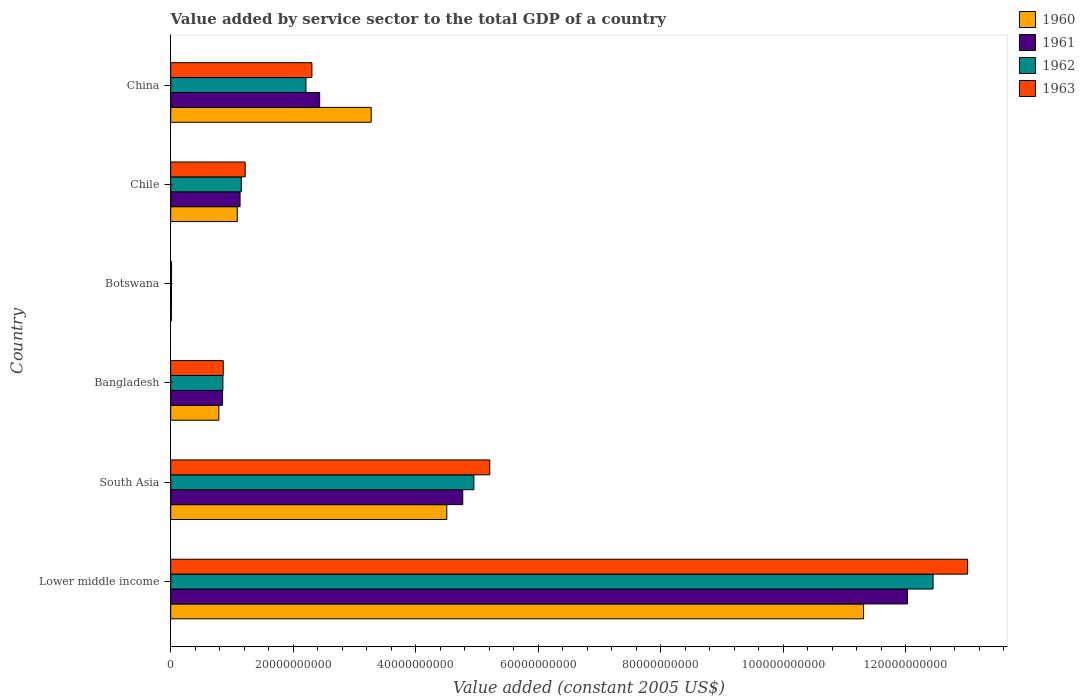How many different coloured bars are there?
Your answer should be very brief. 4. What is the label of the 1st group of bars from the top?
Provide a succinct answer. China. What is the value added by service sector in 1960 in South Asia?
Your response must be concise. 4.51e+1. Across all countries, what is the maximum value added by service sector in 1962?
Offer a very short reply. 1.24e+11. Across all countries, what is the minimum value added by service sector in 1963?
Provide a succinct answer. 1.45e+08. In which country was the value added by service sector in 1962 maximum?
Provide a succinct answer. Lower middle income. In which country was the value added by service sector in 1960 minimum?
Your answer should be very brief. Botswana. What is the total value added by service sector in 1962 in the graph?
Your answer should be very brief. 2.16e+11. What is the difference between the value added by service sector in 1960 in Bangladesh and that in Botswana?
Keep it short and to the point. 7.75e+09. What is the difference between the value added by service sector in 1962 in Chile and the value added by service sector in 1963 in China?
Your response must be concise. -1.15e+1. What is the average value added by service sector in 1962 per country?
Make the answer very short. 3.60e+1. What is the difference between the value added by service sector in 1963 and value added by service sector in 1961 in South Asia?
Make the answer very short. 4.41e+09. What is the ratio of the value added by service sector in 1961 in Lower middle income to that in South Asia?
Ensure brevity in your answer.  2.52. Is the value added by service sector in 1961 in Bangladesh less than that in South Asia?
Offer a terse response. Yes. What is the difference between the highest and the second highest value added by service sector in 1962?
Offer a very short reply. 7.50e+1. What is the difference between the highest and the lowest value added by service sector in 1962?
Offer a very short reply. 1.24e+11. Is the sum of the value added by service sector in 1961 in Botswana and South Asia greater than the maximum value added by service sector in 1962 across all countries?
Keep it short and to the point. No. Is it the case that in every country, the sum of the value added by service sector in 1961 and value added by service sector in 1962 is greater than the sum of value added by service sector in 1960 and value added by service sector in 1963?
Make the answer very short. No. What does the 1st bar from the top in South Asia represents?
Your response must be concise. 1963. Is it the case that in every country, the sum of the value added by service sector in 1962 and value added by service sector in 1963 is greater than the value added by service sector in 1961?
Provide a short and direct response. Yes. Are all the bars in the graph horizontal?
Your response must be concise. Yes. Does the graph contain any zero values?
Offer a very short reply. No. Does the graph contain grids?
Keep it short and to the point. No. How are the legend labels stacked?
Your answer should be very brief. Vertical. What is the title of the graph?
Keep it short and to the point. Value added by service sector to the total GDP of a country. Does "1986" appear as one of the legend labels in the graph?
Ensure brevity in your answer.  No. What is the label or title of the X-axis?
Your answer should be very brief. Value added (constant 2005 US$). What is the Value added (constant 2005 US$) of 1960 in Lower middle income?
Give a very brief answer. 1.13e+11. What is the Value added (constant 2005 US$) of 1961 in Lower middle income?
Offer a very short reply. 1.20e+11. What is the Value added (constant 2005 US$) of 1962 in Lower middle income?
Provide a succinct answer. 1.24e+11. What is the Value added (constant 2005 US$) of 1963 in Lower middle income?
Your answer should be very brief. 1.30e+11. What is the Value added (constant 2005 US$) in 1960 in South Asia?
Ensure brevity in your answer.  4.51e+1. What is the Value added (constant 2005 US$) in 1961 in South Asia?
Your answer should be compact. 4.77e+1. What is the Value added (constant 2005 US$) of 1962 in South Asia?
Your response must be concise. 4.95e+1. What is the Value added (constant 2005 US$) in 1963 in South Asia?
Offer a very short reply. 5.21e+1. What is the Value added (constant 2005 US$) of 1960 in Bangladesh?
Provide a succinct answer. 7.86e+09. What is the Value added (constant 2005 US$) in 1961 in Bangladesh?
Offer a terse response. 8.47e+09. What is the Value added (constant 2005 US$) in 1962 in Bangladesh?
Your response must be concise. 8.52e+09. What is the Value added (constant 2005 US$) of 1963 in Bangladesh?
Give a very brief answer. 8.58e+09. What is the Value added (constant 2005 US$) in 1960 in Botswana?
Your answer should be compact. 1.11e+08. What is the Value added (constant 2005 US$) in 1961 in Botswana?
Ensure brevity in your answer.  1.22e+08. What is the Value added (constant 2005 US$) in 1962 in Botswana?
Provide a succinct answer. 1.32e+08. What is the Value added (constant 2005 US$) in 1963 in Botswana?
Offer a very short reply. 1.45e+08. What is the Value added (constant 2005 US$) in 1960 in Chile?
Make the answer very short. 1.09e+1. What is the Value added (constant 2005 US$) of 1961 in Chile?
Offer a very short reply. 1.13e+1. What is the Value added (constant 2005 US$) of 1962 in Chile?
Give a very brief answer. 1.15e+1. What is the Value added (constant 2005 US$) in 1963 in Chile?
Give a very brief answer. 1.22e+1. What is the Value added (constant 2005 US$) of 1960 in China?
Your response must be concise. 3.27e+1. What is the Value added (constant 2005 US$) in 1961 in China?
Offer a terse response. 2.43e+1. What is the Value added (constant 2005 US$) in 1962 in China?
Offer a terse response. 2.21e+1. What is the Value added (constant 2005 US$) of 1963 in China?
Provide a short and direct response. 2.30e+1. Across all countries, what is the maximum Value added (constant 2005 US$) in 1960?
Ensure brevity in your answer.  1.13e+11. Across all countries, what is the maximum Value added (constant 2005 US$) of 1961?
Ensure brevity in your answer.  1.20e+11. Across all countries, what is the maximum Value added (constant 2005 US$) in 1962?
Offer a very short reply. 1.24e+11. Across all countries, what is the maximum Value added (constant 2005 US$) in 1963?
Provide a succinct answer. 1.30e+11. Across all countries, what is the minimum Value added (constant 2005 US$) in 1960?
Offer a very short reply. 1.11e+08. Across all countries, what is the minimum Value added (constant 2005 US$) of 1961?
Keep it short and to the point. 1.22e+08. Across all countries, what is the minimum Value added (constant 2005 US$) in 1962?
Provide a short and direct response. 1.32e+08. Across all countries, what is the minimum Value added (constant 2005 US$) in 1963?
Offer a terse response. 1.45e+08. What is the total Value added (constant 2005 US$) in 1960 in the graph?
Offer a terse response. 2.10e+11. What is the total Value added (constant 2005 US$) of 1961 in the graph?
Provide a succinct answer. 2.12e+11. What is the total Value added (constant 2005 US$) of 1962 in the graph?
Ensure brevity in your answer.  2.16e+11. What is the total Value added (constant 2005 US$) in 1963 in the graph?
Give a very brief answer. 2.26e+11. What is the difference between the Value added (constant 2005 US$) in 1960 in Lower middle income and that in South Asia?
Keep it short and to the point. 6.80e+1. What is the difference between the Value added (constant 2005 US$) of 1961 in Lower middle income and that in South Asia?
Your answer should be very brief. 7.26e+1. What is the difference between the Value added (constant 2005 US$) of 1962 in Lower middle income and that in South Asia?
Ensure brevity in your answer.  7.50e+1. What is the difference between the Value added (constant 2005 US$) of 1963 in Lower middle income and that in South Asia?
Provide a succinct answer. 7.80e+1. What is the difference between the Value added (constant 2005 US$) of 1960 in Lower middle income and that in Bangladesh?
Offer a terse response. 1.05e+11. What is the difference between the Value added (constant 2005 US$) in 1961 in Lower middle income and that in Bangladesh?
Your answer should be compact. 1.12e+11. What is the difference between the Value added (constant 2005 US$) in 1962 in Lower middle income and that in Bangladesh?
Give a very brief answer. 1.16e+11. What is the difference between the Value added (constant 2005 US$) of 1963 in Lower middle income and that in Bangladesh?
Offer a very short reply. 1.21e+11. What is the difference between the Value added (constant 2005 US$) of 1960 in Lower middle income and that in Botswana?
Provide a short and direct response. 1.13e+11. What is the difference between the Value added (constant 2005 US$) in 1961 in Lower middle income and that in Botswana?
Offer a terse response. 1.20e+11. What is the difference between the Value added (constant 2005 US$) of 1962 in Lower middle income and that in Botswana?
Your response must be concise. 1.24e+11. What is the difference between the Value added (constant 2005 US$) in 1963 in Lower middle income and that in Botswana?
Your answer should be very brief. 1.30e+11. What is the difference between the Value added (constant 2005 US$) in 1960 in Lower middle income and that in Chile?
Give a very brief answer. 1.02e+11. What is the difference between the Value added (constant 2005 US$) in 1961 in Lower middle income and that in Chile?
Give a very brief answer. 1.09e+11. What is the difference between the Value added (constant 2005 US$) of 1962 in Lower middle income and that in Chile?
Your answer should be compact. 1.13e+11. What is the difference between the Value added (constant 2005 US$) in 1963 in Lower middle income and that in Chile?
Your response must be concise. 1.18e+11. What is the difference between the Value added (constant 2005 US$) in 1960 in Lower middle income and that in China?
Your answer should be very brief. 8.04e+1. What is the difference between the Value added (constant 2005 US$) of 1961 in Lower middle income and that in China?
Give a very brief answer. 9.59e+1. What is the difference between the Value added (constant 2005 US$) in 1962 in Lower middle income and that in China?
Make the answer very short. 1.02e+11. What is the difference between the Value added (constant 2005 US$) in 1963 in Lower middle income and that in China?
Provide a succinct answer. 1.07e+11. What is the difference between the Value added (constant 2005 US$) in 1960 in South Asia and that in Bangladesh?
Offer a terse response. 3.72e+1. What is the difference between the Value added (constant 2005 US$) of 1961 in South Asia and that in Bangladesh?
Your answer should be very brief. 3.92e+1. What is the difference between the Value added (constant 2005 US$) of 1962 in South Asia and that in Bangladesh?
Provide a short and direct response. 4.10e+1. What is the difference between the Value added (constant 2005 US$) of 1963 in South Asia and that in Bangladesh?
Offer a very short reply. 4.35e+1. What is the difference between the Value added (constant 2005 US$) of 1960 in South Asia and that in Botswana?
Provide a short and direct response. 4.50e+1. What is the difference between the Value added (constant 2005 US$) in 1961 in South Asia and that in Botswana?
Provide a short and direct response. 4.75e+1. What is the difference between the Value added (constant 2005 US$) in 1962 in South Asia and that in Botswana?
Ensure brevity in your answer.  4.93e+1. What is the difference between the Value added (constant 2005 US$) of 1963 in South Asia and that in Botswana?
Provide a short and direct response. 5.19e+1. What is the difference between the Value added (constant 2005 US$) in 1960 in South Asia and that in Chile?
Your response must be concise. 3.42e+1. What is the difference between the Value added (constant 2005 US$) in 1961 in South Asia and that in Chile?
Provide a succinct answer. 3.63e+1. What is the difference between the Value added (constant 2005 US$) in 1962 in South Asia and that in Chile?
Provide a short and direct response. 3.80e+1. What is the difference between the Value added (constant 2005 US$) of 1963 in South Asia and that in Chile?
Make the answer very short. 3.99e+1. What is the difference between the Value added (constant 2005 US$) in 1960 in South Asia and that in China?
Keep it short and to the point. 1.23e+1. What is the difference between the Value added (constant 2005 US$) in 1961 in South Asia and that in China?
Keep it short and to the point. 2.34e+1. What is the difference between the Value added (constant 2005 US$) in 1962 in South Asia and that in China?
Give a very brief answer. 2.74e+1. What is the difference between the Value added (constant 2005 US$) in 1963 in South Asia and that in China?
Keep it short and to the point. 2.90e+1. What is the difference between the Value added (constant 2005 US$) of 1960 in Bangladesh and that in Botswana?
Give a very brief answer. 7.75e+09. What is the difference between the Value added (constant 2005 US$) of 1961 in Bangladesh and that in Botswana?
Make the answer very short. 8.35e+09. What is the difference between the Value added (constant 2005 US$) in 1962 in Bangladesh and that in Botswana?
Provide a short and direct response. 8.39e+09. What is the difference between the Value added (constant 2005 US$) in 1963 in Bangladesh and that in Botswana?
Give a very brief answer. 8.43e+09. What is the difference between the Value added (constant 2005 US$) of 1960 in Bangladesh and that in Chile?
Provide a succinct answer. -3.01e+09. What is the difference between the Value added (constant 2005 US$) in 1961 in Bangladesh and that in Chile?
Your answer should be very brief. -2.85e+09. What is the difference between the Value added (constant 2005 US$) in 1962 in Bangladesh and that in Chile?
Ensure brevity in your answer.  -3.00e+09. What is the difference between the Value added (constant 2005 US$) in 1963 in Bangladesh and that in Chile?
Ensure brevity in your answer.  -3.58e+09. What is the difference between the Value added (constant 2005 US$) of 1960 in Bangladesh and that in China?
Your answer should be very brief. -2.49e+1. What is the difference between the Value added (constant 2005 US$) of 1961 in Bangladesh and that in China?
Ensure brevity in your answer.  -1.58e+1. What is the difference between the Value added (constant 2005 US$) of 1962 in Bangladesh and that in China?
Ensure brevity in your answer.  -1.36e+1. What is the difference between the Value added (constant 2005 US$) of 1963 in Bangladesh and that in China?
Keep it short and to the point. -1.45e+1. What is the difference between the Value added (constant 2005 US$) of 1960 in Botswana and that in Chile?
Your answer should be very brief. -1.08e+1. What is the difference between the Value added (constant 2005 US$) in 1961 in Botswana and that in Chile?
Provide a short and direct response. -1.12e+1. What is the difference between the Value added (constant 2005 US$) of 1962 in Botswana and that in Chile?
Offer a very short reply. -1.14e+1. What is the difference between the Value added (constant 2005 US$) in 1963 in Botswana and that in Chile?
Make the answer very short. -1.20e+1. What is the difference between the Value added (constant 2005 US$) in 1960 in Botswana and that in China?
Offer a very short reply. -3.26e+1. What is the difference between the Value added (constant 2005 US$) of 1961 in Botswana and that in China?
Your answer should be compact. -2.42e+1. What is the difference between the Value added (constant 2005 US$) of 1962 in Botswana and that in China?
Your answer should be compact. -2.19e+1. What is the difference between the Value added (constant 2005 US$) of 1963 in Botswana and that in China?
Your answer should be very brief. -2.29e+1. What is the difference between the Value added (constant 2005 US$) in 1960 in Chile and that in China?
Your response must be concise. -2.19e+1. What is the difference between the Value added (constant 2005 US$) of 1961 in Chile and that in China?
Offer a very short reply. -1.30e+1. What is the difference between the Value added (constant 2005 US$) of 1962 in Chile and that in China?
Offer a very short reply. -1.05e+1. What is the difference between the Value added (constant 2005 US$) in 1963 in Chile and that in China?
Ensure brevity in your answer.  -1.09e+1. What is the difference between the Value added (constant 2005 US$) of 1960 in Lower middle income and the Value added (constant 2005 US$) of 1961 in South Asia?
Ensure brevity in your answer.  6.54e+1. What is the difference between the Value added (constant 2005 US$) in 1960 in Lower middle income and the Value added (constant 2005 US$) in 1962 in South Asia?
Make the answer very short. 6.36e+1. What is the difference between the Value added (constant 2005 US$) of 1960 in Lower middle income and the Value added (constant 2005 US$) of 1963 in South Asia?
Offer a terse response. 6.10e+1. What is the difference between the Value added (constant 2005 US$) in 1961 in Lower middle income and the Value added (constant 2005 US$) in 1962 in South Asia?
Your response must be concise. 7.08e+1. What is the difference between the Value added (constant 2005 US$) in 1961 in Lower middle income and the Value added (constant 2005 US$) in 1963 in South Asia?
Offer a very short reply. 6.82e+1. What is the difference between the Value added (constant 2005 US$) in 1962 in Lower middle income and the Value added (constant 2005 US$) in 1963 in South Asia?
Ensure brevity in your answer.  7.24e+1. What is the difference between the Value added (constant 2005 US$) of 1960 in Lower middle income and the Value added (constant 2005 US$) of 1961 in Bangladesh?
Keep it short and to the point. 1.05e+11. What is the difference between the Value added (constant 2005 US$) of 1960 in Lower middle income and the Value added (constant 2005 US$) of 1962 in Bangladesh?
Provide a short and direct response. 1.05e+11. What is the difference between the Value added (constant 2005 US$) in 1960 in Lower middle income and the Value added (constant 2005 US$) in 1963 in Bangladesh?
Offer a very short reply. 1.05e+11. What is the difference between the Value added (constant 2005 US$) in 1961 in Lower middle income and the Value added (constant 2005 US$) in 1962 in Bangladesh?
Your answer should be very brief. 1.12e+11. What is the difference between the Value added (constant 2005 US$) of 1961 in Lower middle income and the Value added (constant 2005 US$) of 1963 in Bangladesh?
Give a very brief answer. 1.12e+11. What is the difference between the Value added (constant 2005 US$) in 1962 in Lower middle income and the Value added (constant 2005 US$) in 1963 in Bangladesh?
Offer a terse response. 1.16e+11. What is the difference between the Value added (constant 2005 US$) in 1960 in Lower middle income and the Value added (constant 2005 US$) in 1961 in Botswana?
Your answer should be compact. 1.13e+11. What is the difference between the Value added (constant 2005 US$) of 1960 in Lower middle income and the Value added (constant 2005 US$) of 1962 in Botswana?
Your answer should be very brief. 1.13e+11. What is the difference between the Value added (constant 2005 US$) of 1960 in Lower middle income and the Value added (constant 2005 US$) of 1963 in Botswana?
Your response must be concise. 1.13e+11. What is the difference between the Value added (constant 2005 US$) of 1961 in Lower middle income and the Value added (constant 2005 US$) of 1962 in Botswana?
Provide a short and direct response. 1.20e+11. What is the difference between the Value added (constant 2005 US$) of 1961 in Lower middle income and the Value added (constant 2005 US$) of 1963 in Botswana?
Give a very brief answer. 1.20e+11. What is the difference between the Value added (constant 2005 US$) of 1962 in Lower middle income and the Value added (constant 2005 US$) of 1963 in Botswana?
Your answer should be very brief. 1.24e+11. What is the difference between the Value added (constant 2005 US$) in 1960 in Lower middle income and the Value added (constant 2005 US$) in 1961 in Chile?
Provide a succinct answer. 1.02e+11. What is the difference between the Value added (constant 2005 US$) in 1960 in Lower middle income and the Value added (constant 2005 US$) in 1962 in Chile?
Give a very brief answer. 1.02e+11. What is the difference between the Value added (constant 2005 US$) of 1960 in Lower middle income and the Value added (constant 2005 US$) of 1963 in Chile?
Keep it short and to the point. 1.01e+11. What is the difference between the Value added (constant 2005 US$) in 1961 in Lower middle income and the Value added (constant 2005 US$) in 1962 in Chile?
Offer a terse response. 1.09e+11. What is the difference between the Value added (constant 2005 US$) in 1961 in Lower middle income and the Value added (constant 2005 US$) in 1963 in Chile?
Make the answer very short. 1.08e+11. What is the difference between the Value added (constant 2005 US$) in 1962 in Lower middle income and the Value added (constant 2005 US$) in 1963 in Chile?
Provide a short and direct response. 1.12e+11. What is the difference between the Value added (constant 2005 US$) of 1960 in Lower middle income and the Value added (constant 2005 US$) of 1961 in China?
Offer a very short reply. 8.88e+1. What is the difference between the Value added (constant 2005 US$) of 1960 in Lower middle income and the Value added (constant 2005 US$) of 1962 in China?
Your response must be concise. 9.10e+1. What is the difference between the Value added (constant 2005 US$) of 1960 in Lower middle income and the Value added (constant 2005 US$) of 1963 in China?
Your answer should be compact. 9.00e+1. What is the difference between the Value added (constant 2005 US$) of 1961 in Lower middle income and the Value added (constant 2005 US$) of 1962 in China?
Ensure brevity in your answer.  9.82e+1. What is the difference between the Value added (constant 2005 US$) of 1961 in Lower middle income and the Value added (constant 2005 US$) of 1963 in China?
Provide a short and direct response. 9.72e+1. What is the difference between the Value added (constant 2005 US$) in 1962 in Lower middle income and the Value added (constant 2005 US$) in 1963 in China?
Ensure brevity in your answer.  1.01e+11. What is the difference between the Value added (constant 2005 US$) in 1960 in South Asia and the Value added (constant 2005 US$) in 1961 in Bangladesh?
Provide a succinct answer. 3.66e+1. What is the difference between the Value added (constant 2005 US$) in 1960 in South Asia and the Value added (constant 2005 US$) in 1962 in Bangladesh?
Give a very brief answer. 3.65e+1. What is the difference between the Value added (constant 2005 US$) in 1960 in South Asia and the Value added (constant 2005 US$) in 1963 in Bangladesh?
Offer a very short reply. 3.65e+1. What is the difference between the Value added (constant 2005 US$) in 1961 in South Asia and the Value added (constant 2005 US$) in 1962 in Bangladesh?
Give a very brief answer. 3.91e+1. What is the difference between the Value added (constant 2005 US$) of 1961 in South Asia and the Value added (constant 2005 US$) of 1963 in Bangladesh?
Your answer should be very brief. 3.91e+1. What is the difference between the Value added (constant 2005 US$) of 1962 in South Asia and the Value added (constant 2005 US$) of 1963 in Bangladesh?
Ensure brevity in your answer.  4.09e+1. What is the difference between the Value added (constant 2005 US$) in 1960 in South Asia and the Value added (constant 2005 US$) in 1961 in Botswana?
Make the answer very short. 4.49e+1. What is the difference between the Value added (constant 2005 US$) in 1960 in South Asia and the Value added (constant 2005 US$) in 1962 in Botswana?
Your answer should be compact. 4.49e+1. What is the difference between the Value added (constant 2005 US$) of 1960 in South Asia and the Value added (constant 2005 US$) of 1963 in Botswana?
Offer a very short reply. 4.49e+1. What is the difference between the Value added (constant 2005 US$) in 1961 in South Asia and the Value added (constant 2005 US$) in 1962 in Botswana?
Offer a terse response. 4.75e+1. What is the difference between the Value added (constant 2005 US$) of 1961 in South Asia and the Value added (constant 2005 US$) of 1963 in Botswana?
Keep it short and to the point. 4.75e+1. What is the difference between the Value added (constant 2005 US$) in 1962 in South Asia and the Value added (constant 2005 US$) in 1963 in Botswana?
Keep it short and to the point. 4.93e+1. What is the difference between the Value added (constant 2005 US$) of 1960 in South Asia and the Value added (constant 2005 US$) of 1961 in Chile?
Provide a succinct answer. 3.37e+1. What is the difference between the Value added (constant 2005 US$) in 1960 in South Asia and the Value added (constant 2005 US$) in 1962 in Chile?
Provide a succinct answer. 3.35e+1. What is the difference between the Value added (constant 2005 US$) of 1960 in South Asia and the Value added (constant 2005 US$) of 1963 in Chile?
Offer a very short reply. 3.29e+1. What is the difference between the Value added (constant 2005 US$) of 1961 in South Asia and the Value added (constant 2005 US$) of 1962 in Chile?
Make the answer very short. 3.61e+1. What is the difference between the Value added (constant 2005 US$) in 1961 in South Asia and the Value added (constant 2005 US$) in 1963 in Chile?
Offer a terse response. 3.55e+1. What is the difference between the Value added (constant 2005 US$) in 1962 in South Asia and the Value added (constant 2005 US$) in 1963 in Chile?
Ensure brevity in your answer.  3.73e+1. What is the difference between the Value added (constant 2005 US$) of 1960 in South Asia and the Value added (constant 2005 US$) of 1961 in China?
Your answer should be very brief. 2.08e+1. What is the difference between the Value added (constant 2005 US$) of 1960 in South Asia and the Value added (constant 2005 US$) of 1962 in China?
Your answer should be compact. 2.30e+1. What is the difference between the Value added (constant 2005 US$) of 1960 in South Asia and the Value added (constant 2005 US$) of 1963 in China?
Offer a very short reply. 2.20e+1. What is the difference between the Value added (constant 2005 US$) in 1961 in South Asia and the Value added (constant 2005 US$) in 1962 in China?
Your answer should be compact. 2.56e+1. What is the difference between the Value added (constant 2005 US$) in 1961 in South Asia and the Value added (constant 2005 US$) in 1963 in China?
Keep it short and to the point. 2.46e+1. What is the difference between the Value added (constant 2005 US$) of 1962 in South Asia and the Value added (constant 2005 US$) of 1963 in China?
Provide a succinct answer. 2.64e+1. What is the difference between the Value added (constant 2005 US$) of 1960 in Bangladesh and the Value added (constant 2005 US$) of 1961 in Botswana?
Your response must be concise. 7.74e+09. What is the difference between the Value added (constant 2005 US$) of 1960 in Bangladesh and the Value added (constant 2005 US$) of 1962 in Botswana?
Your response must be concise. 7.73e+09. What is the difference between the Value added (constant 2005 US$) of 1960 in Bangladesh and the Value added (constant 2005 US$) of 1963 in Botswana?
Ensure brevity in your answer.  7.72e+09. What is the difference between the Value added (constant 2005 US$) of 1961 in Bangladesh and the Value added (constant 2005 US$) of 1962 in Botswana?
Your answer should be very brief. 8.34e+09. What is the difference between the Value added (constant 2005 US$) in 1961 in Bangladesh and the Value added (constant 2005 US$) in 1963 in Botswana?
Keep it short and to the point. 8.32e+09. What is the difference between the Value added (constant 2005 US$) of 1962 in Bangladesh and the Value added (constant 2005 US$) of 1963 in Botswana?
Your response must be concise. 8.38e+09. What is the difference between the Value added (constant 2005 US$) of 1960 in Bangladesh and the Value added (constant 2005 US$) of 1961 in Chile?
Ensure brevity in your answer.  -3.46e+09. What is the difference between the Value added (constant 2005 US$) of 1960 in Bangladesh and the Value added (constant 2005 US$) of 1962 in Chile?
Your answer should be very brief. -3.67e+09. What is the difference between the Value added (constant 2005 US$) in 1960 in Bangladesh and the Value added (constant 2005 US$) in 1963 in Chile?
Your response must be concise. -4.29e+09. What is the difference between the Value added (constant 2005 US$) of 1961 in Bangladesh and the Value added (constant 2005 US$) of 1962 in Chile?
Offer a very short reply. -3.06e+09. What is the difference between the Value added (constant 2005 US$) of 1961 in Bangladesh and the Value added (constant 2005 US$) of 1963 in Chile?
Keep it short and to the point. -3.68e+09. What is the difference between the Value added (constant 2005 US$) of 1962 in Bangladesh and the Value added (constant 2005 US$) of 1963 in Chile?
Make the answer very short. -3.63e+09. What is the difference between the Value added (constant 2005 US$) of 1960 in Bangladesh and the Value added (constant 2005 US$) of 1961 in China?
Your answer should be very brief. -1.65e+1. What is the difference between the Value added (constant 2005 US$) of 1960 in Bangladesh and the Value added (constant 2005 US$) of 1962 in China?
Offer a very short reply. -1.42e+1. What is the difference between the Value added (constant 2005 US$) of 1960 in Bangladesh and the Value added (constant 2005 US$) of 1963 in China?
Provide a succinct answer. -1.52e+1. What is the difference between the Value added (constant 2005 US$) in 1961 in Bangladesh and the Value added (constant 2005 US$) in 1962 in China?
Your answer should be very brief. -1.36e+1. What is the difference between the Value added (constant 2005 US$) of 1961 in Bangladesh and the Value added (constant 2005 US$) of 1963 in China?
Provide a succinct answer. -1.46e+1. What is the difference between the Value added (constant 2005 US$) of 1962 in Bangladesh and the Value added (constant 2005 US$) of 1963 in China?
Your answer should be very brief. -1.45e+1. What is the difference between the Value added (constant 2005 US$) in 1960 in Botswana and the Value added (constant 2005 US$) in 1961 in Chile?
Provide a succinct answer. -1.12e+1. What is the difference between the Value added (constant 2005 US$) of 1960 in Botswana and the Value added (constant 2005 US$) of 1962 in Chile?
Your response must be concise. -1.14e+1. What is the difference between the Value added (constant 2005 US$) in 1960 in Botswana and the Value added (constant 2005 US$) in 1963 in Chile?
Offer a very short reply. -1.20e+1. What is the difference between the Value added (constant 2005 US$) of 1961 in Botswana and the Value added (constant 2005 US$) of 1962 in Chile?
Ensure brevity in your answer.  -1.14e+1. What is the difference between the Value added (constant 2005 US$) of 1961 in Botswana and the Value added (constant 2005 US$) of 1963 in Chile?
Ensure brevity in your answer.  -1.20e+1. What is the difference between the Value added (constant 2005 US$) of 1962 in Botswana and the Value added (constant 2005 US$) of 1963 in Chile?
Give a very brief answer. -1.20e+1. What is the difference between the Value added (constant 2005 US$) in 1960 in Botswana and the Value added (constant 2005 US$) in 1961 in China?
Your answer should be compact. -2.42e+1. What is the difference between the Value added (constant 2005 US$) of 1960 in Botswana and the Value added (constant 2005 US$) of 1962 in China?
Give a very brief answer. -2.20e+1. What is the difference between the Value added (constant 2005 US$) in 1960 in Botswana and the Value added (constant 2005 US$) in 1963 in China?
Ensure brevity in your answer.  -2.29e+1. What is the difference between the Value added (constant 2005 US$) in 1961 in Botswana and the Value added (constant 2005 US$) in 1962 in China?
Your answer should be compact. -2.20e+1. What is the difference between the Value added (constant 2005 US$) in 1961 in Botswana and the Value added (constant 2005 US$) in 1963 in China?
Provide a short and direct response. -2.29e+1. What is the difference between the Value added (constant 2005 US$) in 1962 in Botswana and the Value added (constant 2005 US$) in 1963 in China?
Offer a terse response. -2.29e+1. What is the difference between the Value added (constant 2005 US$) of 1960 in Chile and the Value added (constant 2005 US$) of 1961 in China?
Keep it short and to the point. -1.34e+1. What is the difference between the Value added (constant 2005 US$) in 1960 in Chile and the Value added (constant 2005 US$) in 1962 in China?
Your answer should be very brief. -1.12e+1. What is the difference between the Value added (constant 2005 US$) of 1960 in Chile and the Value added (constant 2005 US$) of 1963 in China?
Keep it short and to the point. -1.22e+1. What is the difference between the Value added (constant 2005 US$) in 1961 in Chile and the Value added (constant 2005 US$) in 1962 in China?
Offer a very short reply. -1.08e+1. What is the difference between the Value added (constant 2005 US$) of 1961 in Chile and the Value added (constant 2005 US$) of 1963 in China?
Your response must be concise. -1.17e+1. What is the difference between the Value added (constant 2005 US$) in 1962 in Chile and the Value added (constant 2005 US$) in 1963 in China?
Ensure brevity in your answer.  -1.15e+1. What is the average Value added (constant 2005 US$) in 1960 per country?
Offer a terse response. 3.50e+1. What is the average Value added (constant 2005 US$) of 1961 per country?
Your response must be concise. 3.54e+1. What is the average Value added (constant 2005 US$) in 1962 per country?
Give a very brief answer. 3.60e+1. What is the average Value added (constant 2005 US$) in 1963 per country?
Offer a very short reply. 3.77e+1. What is the difference between the Value added (constant 2005 US$) of 1960 and Value added (constant 2005 US$) of 1961 in Lower middle income?
Keep it short and to the point. -7.16e+09. What is the difference between the Value added (constant 2005 US$) in 1960 and Value added (constant 2005 US$) in 1962 in Lower middle income?
Keep it short and to the point. -1.13e+1. What is the difference between the Value added (constant 2005 US$) of 1960 and Value added (constant 2005 US$) of 1963 in Lower middle income?
Your answer should be very brief. -1.70e+1. What is the difference between the Value added (constant 2005 US$) in 1961 and Value added (constant 2005 US$) in 1962 in Lower middle income?
Ensure brevity in your answer.  -4.18e+09. What is the difference between the Value added (constant 2005 US$) in 1961 and Value added (constant 2005 US$) in 1963 in Lower middle income?
Offer a terse response. -9.81e+09. What is the difference between the Value added (constant 2005 US$) in 1962 and Value added (constant 2005 US$) in 1963 in Lower middle income?
Your answer should be compact. -5.63e+09. What is the difference between the Value added (constant 2005 US$) in 1960 and Value added (constant 2005 US$) in 1961 in South Asia?
Your answer should be very brief. -2.61e+09. What is the difference between the Value added (constant 2005 US$) in 1960 and Value added (constant 2005 US$) in 1962 in South Asia?
Provide a short and direct response. -4.42e+09. What is the difference between the Value added (constant 2005 US$) of 1960 and Value added (constant 2005 US$) of 1963 in South Asia?
Ensure brevity in your answer.  -7.01e+09. What is the difference between the Value added (constant 2005 US$) in 1961 and Value added (constant 2005 US$) in 1962 in South Asia?
Offer a terse response. -1.81e+09. What is the difference between the Value added (constant 2005 US$) of 1961 and Value added (constant 2005 US$) of 1963 in South Asia?
Keep it short and to the point. -4.41e+09. What is the difference between the Value added (constant 2005 US$) in 1962 and Value added (constant 2005 US$) in 1963 in South Asia?
Provide a succinct answer. -2.59e+09. What is the difference between the Value added (constant 2005 US$) of 1960 and Value added (constant 2005 US$) of 1961 in Bangladesh?
Your response must be concise. -6.09e+08. What is the difference between the Value added (constant 2005 US$) of 1960 and Value added (constant 2005 US$) of 1962 in Bangladesh?
Provide a short and direct response. -6.62e+08. What is the difference between the Value added (constant 2005 US$) in 1960 and Value added (constant 2005 US$) in 1963 in Bangladesh?
Keep it short and to the point. -7.16e+08. What is the difference between the Value added (constant 2005 US$) in 1961 and Value added (constant 2005 US$) in 1962 in Bangladesh?
Provide a short and direct response. -5.33e+07. What is the difference between the Value added (constant 2005 US$) of 1961 and Value added (constant 2005 US$) of 1963 in Bangladesh?
Make the answer very short. -1.08e+08. What is the difference between the Value added (constant 2005 US$) in 1962 and Value added (constant 2005 US$) in 1963 in Bangladesh?
Your answer should be compact. -5.45e+07. What is the difference between the Value added (constant 2005 US$) of 1960 and Value added (constant 2005 US$) of 1961 in Botswana?
Your response must be concise. -1.12e+07. What is the difference between the Value added (constant 2005 US$) in 1960 and Value added (constant 2005 US$) in 1962 in Botswana?
Your answer should be very brief. -2.17e+07. What is the difference between the Value added (constant 2005 US$) in 1960 and Value added (constant 2005 US$) in 1963 in Botswana?
Your response must be concise. -3.45e+07. What is the difference between the Value added (constant 2005 US$) in 1961 and Value added (constant 2005 US$) in 1962 in Botswana?
Give a very brief answer. -1.05e+07. What is the difference between the Value added (constant 2005 US$) of 1961 and Value added (constant 2005 US$) of 1963 in Botswana?
Provide a succinct answer. -2.33e+07. What is the difference between the Value added (constant 2005 US$) of 1962 and Value added (constant 2005 US$) of 1963 in Botswana?
Your response must be concise. -1.28e+07. What is the difference between the Value added (constant 2005 US$) in 1960 and Value added (constant 2005 US$) in 1961 in Chile?
Offer a terse response. -4.53e+08. What is the difference between the Value added (constant 2005 US$) in 1960 and Value added (constant 2005 US$) in 1962 in Chile?
Give a very brief answer. -6.60e+08. What is the difference between the Value added (constant 2005 US$) of 1960 and Value added (constant 2005 US$) of 1963 in Chile?
Provide a succinct answer. -1.29e+09. What is the difference between the Value added (constant 2005 US$) of 1961 and Value added (constant 2005 US$) of 1962 in Chile?
Offer a terse response. -2.07e+08. What is the difference between the Value added (constant 2005 US$) of 1961 and Value added (constant 2005 US$) of 1963 in Chile?
Give a very brief answer. -8.32e+08. What is the difference between the Value added (constant 2005 US$) of 1962 and Value added (constant 2005 US$) of 1963 in Chile?
Your response must be concise. -6.25e+08. What is the difference between the Value added (constant 2005 US$) in 1960 and Value added (constant 2005 US$) in 1961 in China?
Your answer should be very brief. 8.41e+09. What is the difference between the Value added (constant 2005 US$) in 1960 and Value added (constant 2005 US$) in 1962 in China?
Offer a terse response. 1.06e+1. What is the difference between the Value added (constant 2005 US$) in 1960 and Value added (constant 2005 US$) in 1963 in China?
Your answer should be compact. 9.68e+09. What is the difference between the Value added (constant 2005 US$) of 1961 and Value added (constant 2005 US$) of 1962 in China?
Your answer should be very brief. 2.24e+09. What is the difference between the Value added (constant 2005 US$) of 1961 and Value added (constant 2005 US$) of 1963 in China?
Make the answer very short. 1.27e+09. What is the difference between the Value added (constant 2005 US$) in 1962 and Value added (constant 2005 US$) in 1963 in China?
Offer a terse response. -9.71e+08. What is the ratio of the Value added (constant 2005 US$) in 1960 in Lower middle income to that in South Asia?
Make the answer very short. 2.51. What is the ratio of the Value added (constant 2005 US$) in 1961 in Lower middle income to that in South Asia?
Your answer should be compact. 2.52. What is the ratio of the Value added (constant 2005 US$) of 1962 in Lower middle income to that in South Asia?
Your response must be concise. 2.51. What is the ratio of the Value added (constant 2005 US$) of 1963 in Lower middle income to that in South Asia?
Offer a very short reply. 2.5. What is the ratio of the Value added (constant 2005 US$) in 1960 in Lower middle income to that in Bangladesh?
Make the answer very short. 14.39. What is the ratio of the Value added (constant 2005 US$) of 1961 in Lower middle income to that in Bangladesh?
Your answer should be compact. 14.2. What is the ratio of the Value added (constant 2005 US$) in 1962 in Lower middle income to that in Bangladesh?
Keep it short and to the point. 14.6. What is the ratio of the Value added (constant 2005 US$) in 1963 in Lower middle income to that in Bangladesh?
Offer a very short reply. 15.16. What is the ratio of the Value added (constant 2005 US$) in 1960 in Lower middle income to that in Botswana?
Give a very brief answer. 1022.68. What is the ratio of the Value added (constant 2005 US$) of 1961 in Lower middle income to that in Botswana?
Provide a short and direct response. 987.49. What is the ratio of the Value added (constant 2005 US$) of 1962 in Lower middle income to that in Botswana?
Offer a very short reply. 940.71. What is the ratio of the Value added (constant 2005 US$) in 1963 in Lower middle income to that in Botswana?
Offer a terse response. 896.5. What is the ratio of the Value added (constant 2005 US$) of 1960 in Lower middle income to that in Chile?
Provide a succinct answer. 10.41. What is the ratio of the Value added (constant 2005 US$) of 1961 in Lower middle income to that in Chile?
Make the answer very short. 10.62. What is the ratio of the Value added (constant 2005 US$) in 1962 in Lower middle income to that in Chile?
Provide a succinct answer. 10.79. What is the ratio of the Value added (constant 2005 US$) in 1963 in Lower middle income to that in Chile?
Your response must be concise. 10.7. What is the ratio of the Value added (constant 2005 US$) of 1960 in Lower middle income to that in China?
Your response must be concise. 3.46. What is the ratio of the Value added (constant 2005 US$) in 1961 in Lower middle income to that in China?
Your answer should be compact. 4.95. What is the ratio of the Value added (constant 2005 US$) in 1962 in Lower middle income to that in China?
Offer a terse response. 5.64. What is the ratio of the Value added (constant 2005 US$) of 1963 in Lower middle income to that in China?
Offer a terse response. 5.64. What is the ratio of the Value added (constant 2005 US$) in 1960 in South Asia to that in Bangladesh?
Ensure brevity in your answer.  5.73. What is the ratio of the Value added (constant 2005 US$) in 1961 in South Asia to that in Bangladesh?
Offer a terse response. 5.63. What is the ratio of the Value added (constant 2005 US$) of 1962 in South Asia to that in Bangladesh?
Offer a terse response. 5.81. What is the ratio of the Value added (constant 2005 US$) in 1963 in South Asia to that in Bangladesh?
Your response must be concise. 6.07. What is the ratio of the Value added (constant 2005 US$) in 1960 in South Asia to that in Botswana?
Offer a very short reply. 407.52. What is the ratio of the Value added (constant 2005 US$) in 1961 in South Asia to that in Botswana?
Your answer should be compact. 391.45. What is the ratio of the Value added (constant 2005 US$) in 1962 in South Asia to that in Botswana?
Give a very brief answer. 374.08. What is the ratio of the Value added (constant 2005 US$) of 1963 in South Asia to that in Botswana?
Give a very brief answer. 358.96. What is the ratio of the Value added (constant 2005 US$) in 1960 in South Asia to that in Chile?
Provide a short and direct response. 4.15. What is the ratio of the Value added (constant 2005 US$) of 1961 in South Asia to that in Chile?
Ensure brevity in your answer.  4.21. What is the ratio of the Value added (constant 2005 US$) of 1962 in South Asia to that in Chile?
Give a very brief answer. 4.29. What is the ratio of the Value added (constant 2005 US$) of 1963 in South Asia to that in Chile?
Give a very brief answer. 4.29. What is the ratio of the Value added (constant 2005 US$) in 1960 in South Asia to that in China?
Provide a succinct answer. 1.38. What is the ratio of the Value added (constant 2005 US$) of 1961 in South Asia to that in China?
Keep it short and to the point. 1.96. What is the ratio of the Value added (constant 2005 US$) of 1962 in South Asia to that in China?
Provide a short and direct response. 2.24. What is the ratio of the Value added (constant 2005 US$) of 1963 in South Asia to that in China?
Give a very brief answer. 2.26. What is the ratio of the Value added (constant 2005 US$) of 1960 in Bangladesh to that in Botswana?
Keep it short and to the point. 71.09. What is the ratio of the Value added (constant 2005 US$) of 1961 in Bangladesh to that in Botswana?
Provide a succinct answer. 69.55. What is the ratio of the Value added (constant 2005 US$) in 1962 in Bangladesh to that in Botswana?
Your response must be concise. 64.43. What is the ratio of the Value added (constant 2005 US$) of 1963 in Bangladesh to that in Botswana?
Your answer should be very brief. 59.12. What is the ratio of the Value added (constant 2005 US$) in 1960 in Bangladesh to that in Chile?
Provide a short and direct response. 0.72. What is the ratio of the Value added (constant 2005 US$) of 1961 in Bangladesh to that in Chile?
Keep it short and to the point. 0.75. What is the ratio of the Value added (constant 2005 US$) of 1962 in Bangladesh to that in Chile?
Provide a succinct answer. 0.74. What is the ratio of the Value added (constant 2005 US$) in 1963 in Bangladesh to that in Chile?
Your response must be concise. 0.71. What is the ratio of the Value added (constant 2005 US$) in 1960 in Bangladesh to that in China?
Ensure brevity in your answer.  0.24. What is the ratio of the Value added (constant 2005 US$) of 1961 in Bangladesh to that in China?
Your answer should be very brief. 0.35. What is the ratio of the Value added (constant 2005 US$) of 1962 in Bangladesh to that in China?
Offer a terse response. 0.39. What is the ratio of the Value added (constant 2005 US$) of 1963 in Bangladesh to that in China?
Provide a short and direct response. 0.37. What is the ratio of the Value added (constant 2005 US$) of 1960 in Botswana to that in Chile?
Make the answer very short. 0.01. What is the ratio of the Value added (constant 2005 US$) of 1961 in Botswana to that in Chile?
Your answer should be very brief. 0.01. What is the ratio of the Value added (constant 2005 US$) of 1962 in Botswana to that in Chile?
Offer a terse response. 0.01. What is the ratio of the Value added (constant 2005 US$) of 1963 in Botswana to that in Chile?
Offer a very short reply. 0.01. What is the ratio of the Value added (constant 2005 US$) of 1960 in Botswana to that in China?
Your answer should be very brief. 0. What is the ratio of the Value added (constant 2005 US$) in 1961 in Botswana to that in China?
Ensure brevity in your answer.  0.01. What is the ratio of the Value added (constant 2005 US$) in 1962 in Botswana to that in China?
Your answer should be compact. 0.01. What is the ratio of the Value added (constant 2005 US$) in 1963 in Botswana to that in China?
Provide a succinct answer. 0.01. What is the ratio of the Value added (constant 2005 US$) of 1960 in Chile to that in China?
Give a very brief answer. 0.33. What is the ratio of the Value added (constant 2005 US$) in 1961 in Chile to that in China?
Offer a very short reply. 0.47. What is the ratio of the Value added (constant 2005 US$) of 1962 in Chile to that in China?
Offer a terse response. 0.52. What is the ratio of the Value added (constant 2005 US$) of 1963 in Chile to that in China?
Keep it short and to the point. 0.53. What is the difference between the highest and the second highest Value added (constant 2005 US$) of 1960?
Ensure brevity in your answer.  6.80e+1. What is the difference between the highest and the second highest Value added (constant 2005 US$) in 1961?
Offer a very short reply. 7.26e+1. What is the difference between the highest and the second highest Value added (constant 2005 US$) of 1962?
Your answer should be compact. 7.50e+1. What is the difference between the highest and the second highest Value added (constant 2005 US$) of 1963?
Your answer should be very brief. 7.80e+1. What is the difference between the highest and the lowest Value added (constant 2005 US$) in 1960?
Offer a terse response. 1.13e+11. What is the difference between the highest and the lowest Value added (constant 2005 US$) of 1961?
Provide a succinct answer. 1.20e+11. What is the difference between the highest and the lowest Value added (constant 2005 US$) in 1962?
Your answer should be very brief. 1.24e+11. What is the difference between the highest and the lowest Value added (constant 2005 US$) of 1963?
Provide a short and direct response. 1.30e+11. 